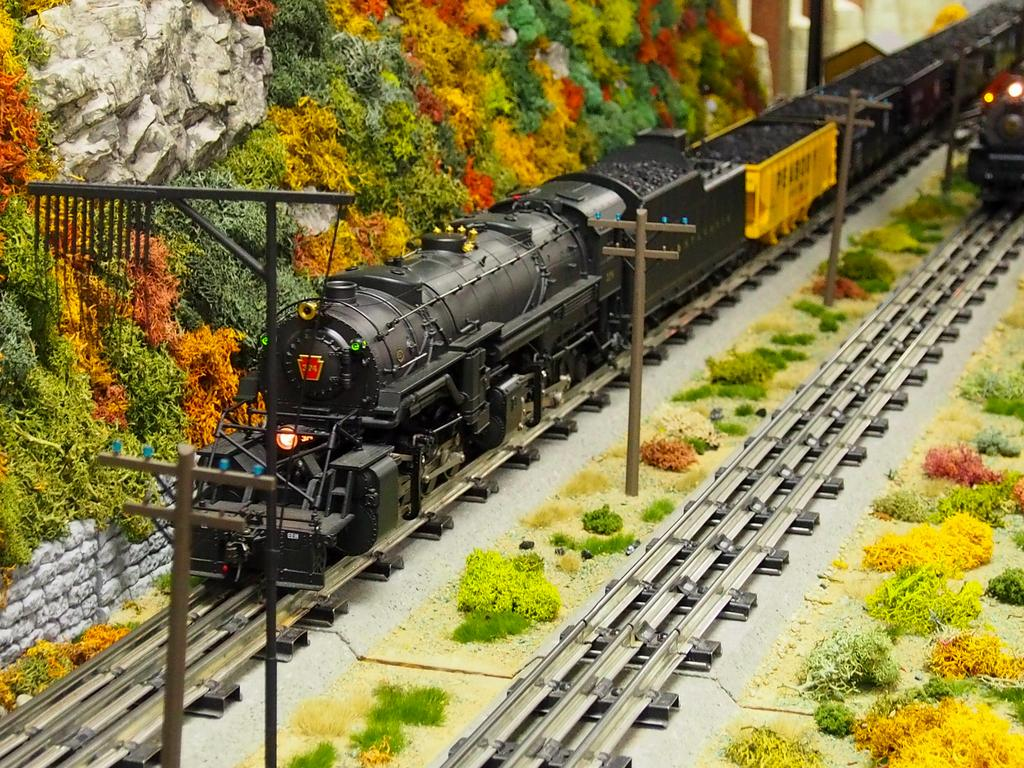What type of objects can be seen in the image? There are toys in the image. Can you describe the specific toys that are visible? There are two trains on tracks in the image. What else can be seen in the image besides the trains? There are poles and plants in the image. What type of bird can be seen perched on the wren in the image? There is no bird or wren present in the image. Is the liquid in the image frozen or melting? There is no liquid present in the image. 